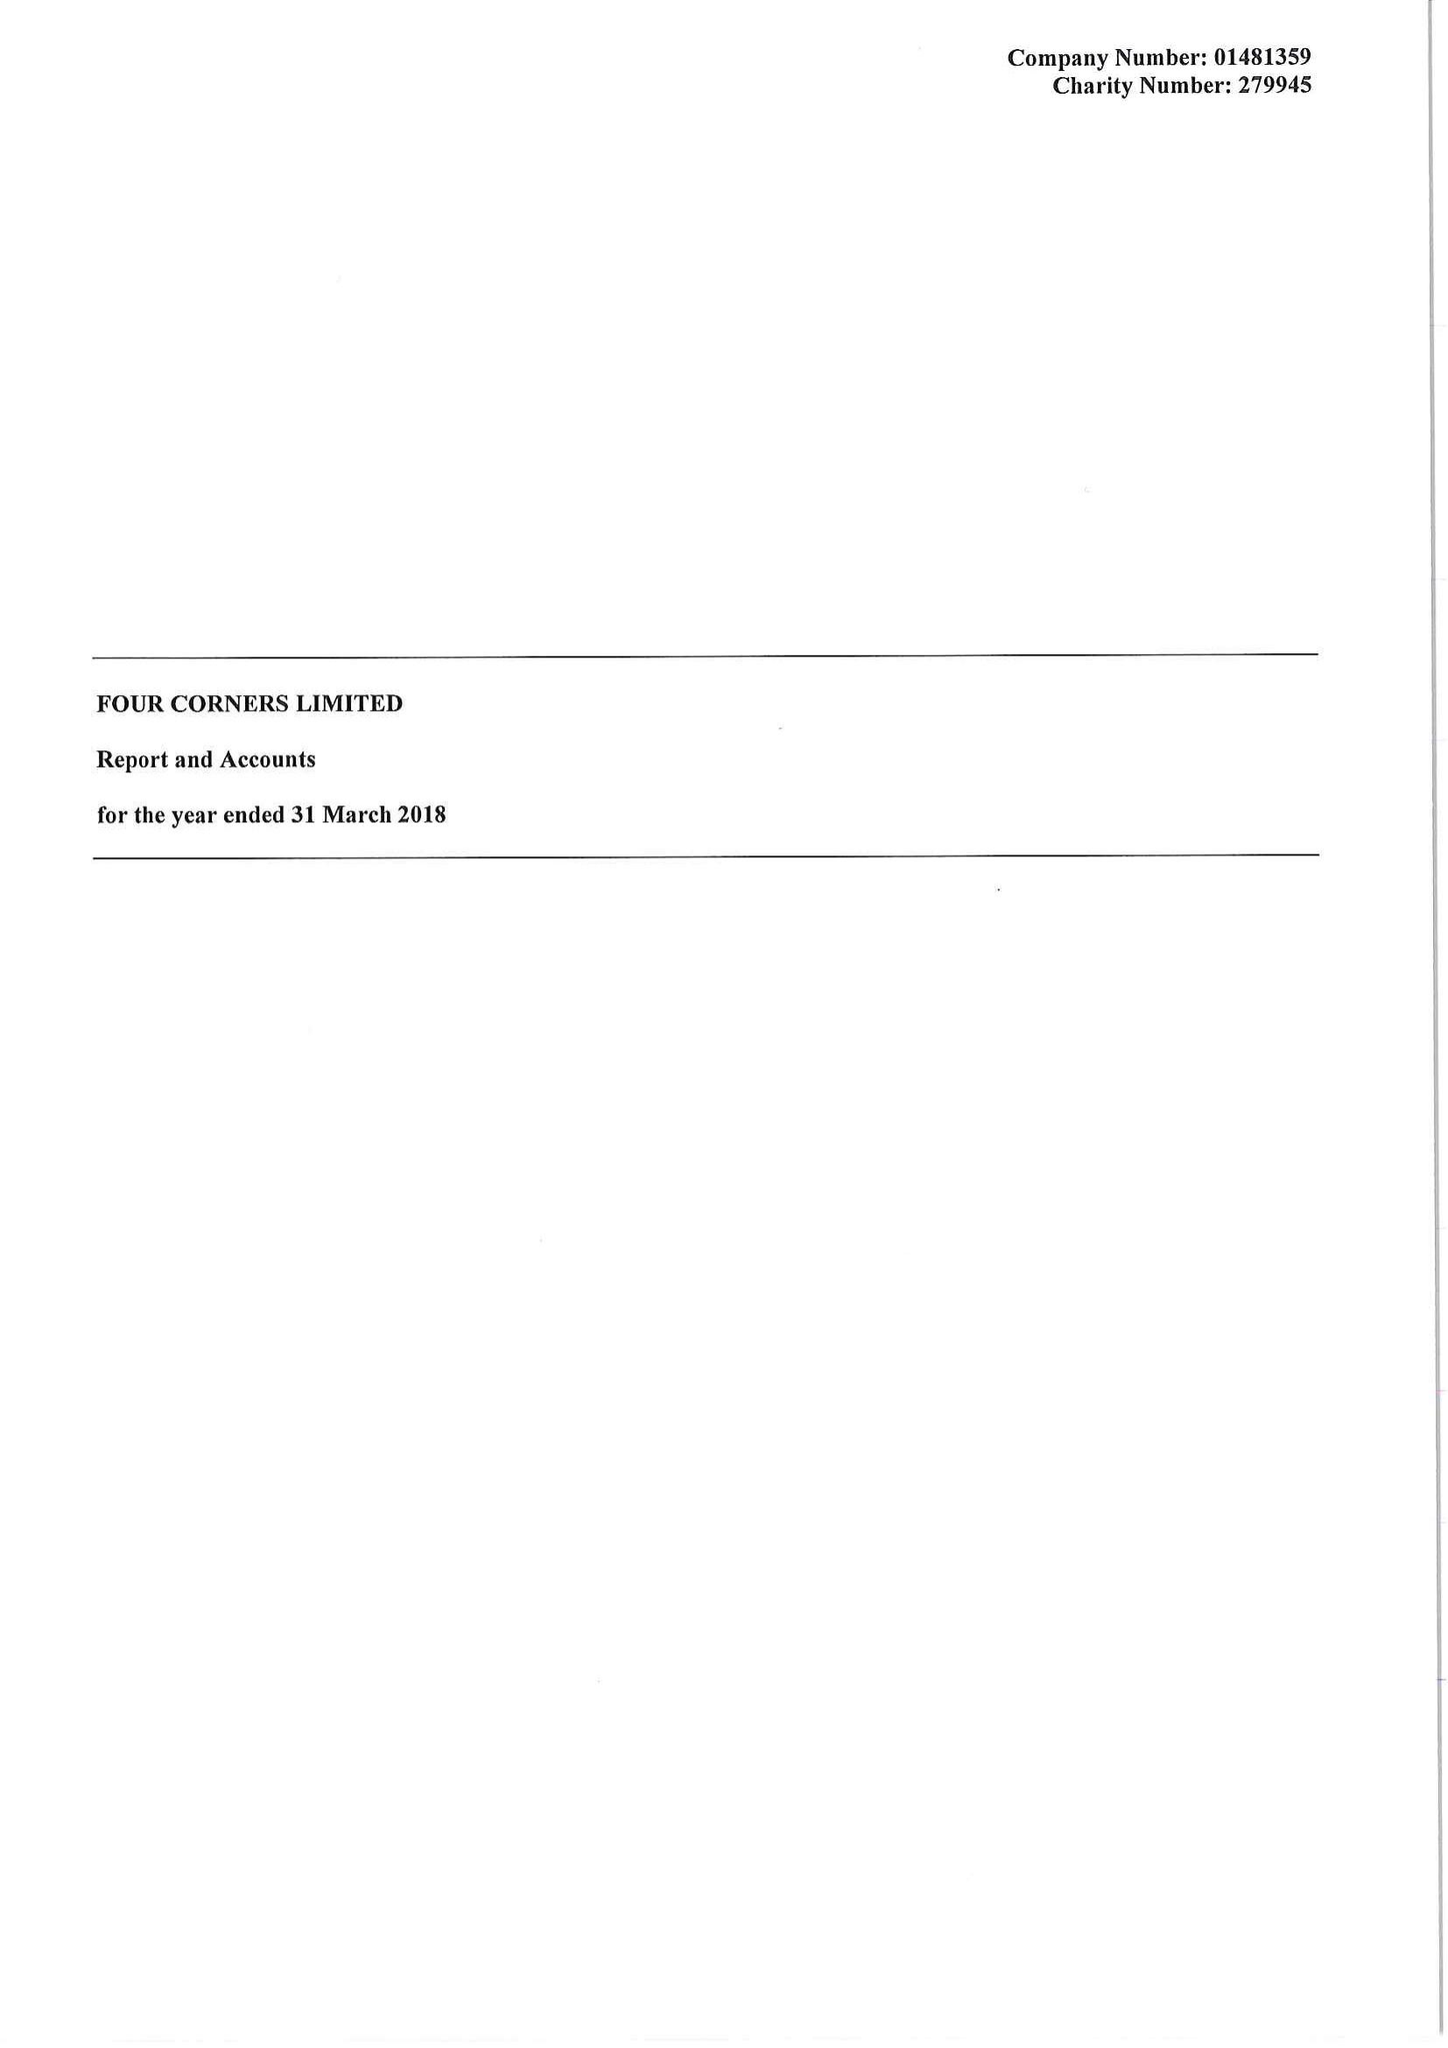What is the value for the spending_annually_in_british_pounds?
Answer the question using a single word or phrase. 434715.00 